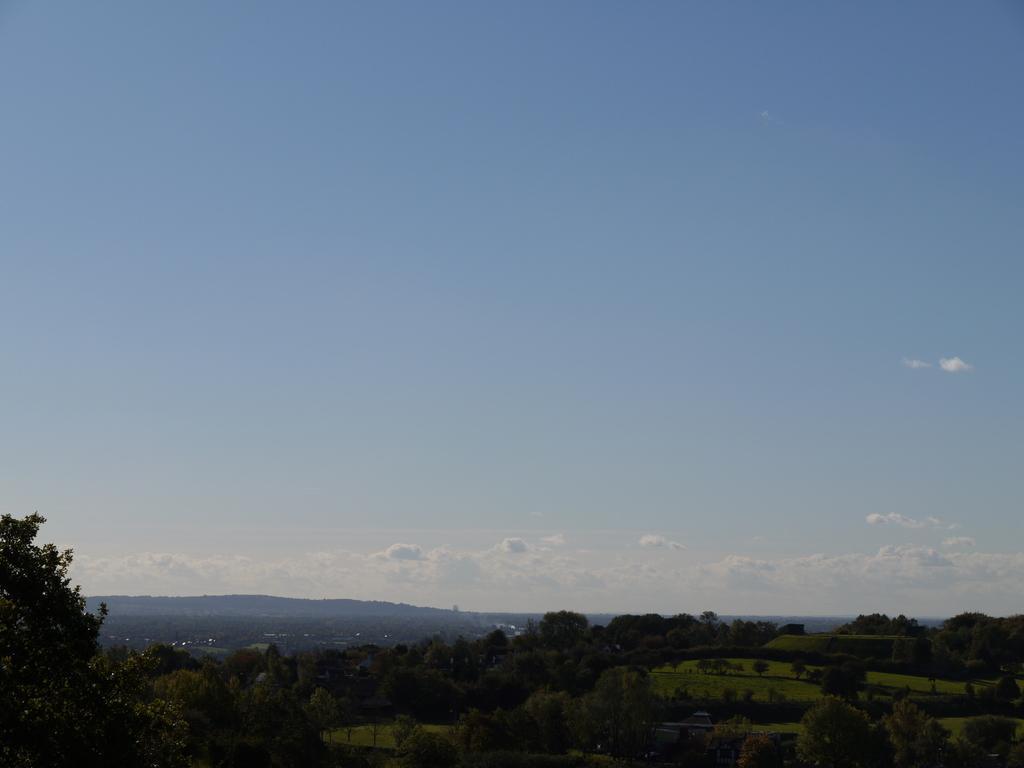Can you describe this image briefly? In this image, at the bottom there are trees, hills, grass, sky and clouds. 